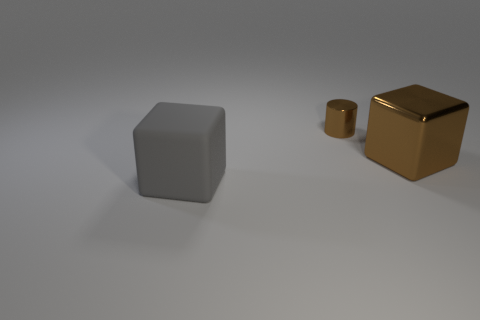Add 2 purple things. How many objects exist? 5 Subtract all blocks. How many objects are left? 1 Add 2 tiny brown things. How many tiny brown things are left? 3 Add 2 large gray matte blocks. How many large gray matte blocks exist? 3 Subtract 0 cyan cylinders. How many objects are left? 3 Subtract all blue rubber spheres. Subtract all gray rubber cubes. How many objects are left? 2 